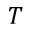Convert formula to latex. <formula><loc_0><loc_0><loc_500><loc_500>T</formula> 